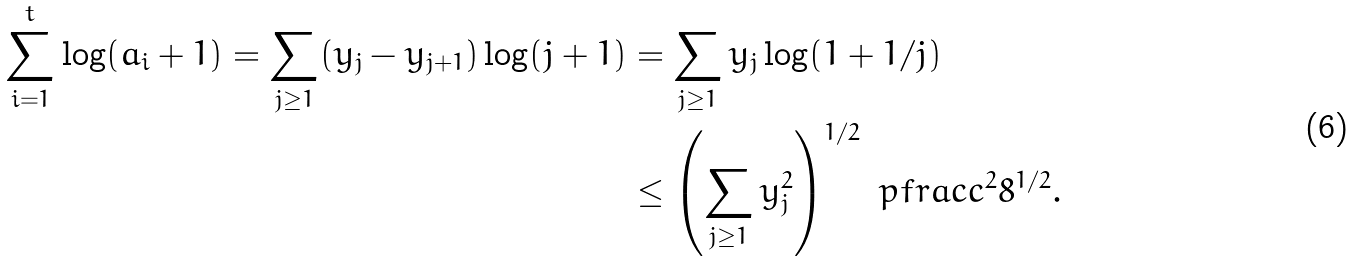Convert formula to latex. <formula><loc_0><loc_0><loc_500><loc_500>\sum _ { i = 1 } ^ { t } \log ( a _ { i } + 1 ) = \sum _ { j \geq 1 } ( y _ { j } - y _ { j + 1 } ) \log ( j + 1 ) & = \sum _ { j \geq 1 } y _ { j } \log ( 1 + 1 / j ) \\ & \leq \left ( \sum _ { j \geq 1 } y _ { j } ^ { 2 } \right ) ^ { 1 / 2 } \ p f r a c { c ^ { 2 } } { 8 } ^ { 1 / 2 } .</formula> 